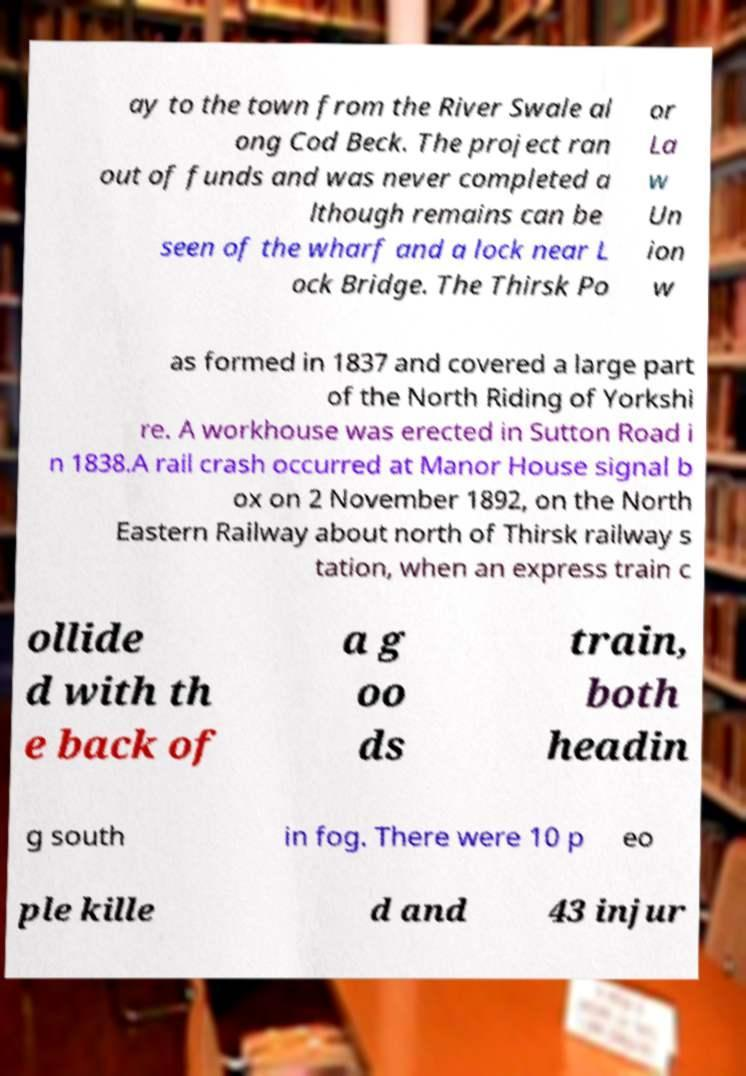Could you assist in decoding the text presented in this image and type it out clearly? ay to the town from the River Swale al ong Cod Beck. The project ran out of funds and was never completed a lthough remains can be seen of the wharf and a lock near L ock Bridge. The Thirsk Po or La w Un ion w as formed in 1837 and covered a large part of the North Riding of Yorkshi re. A workhouse was erected in Sutton Road i n 1838.A rail crash occurred at Manor House signal b ox on 2 November 1892, on the North Eastern Railway about north of Thirsk railway s tation, when an express train c ollide d with th e back of a g oo ds train, both headin g south in fog. There were 10 p eo ple kille d and 43 injur 